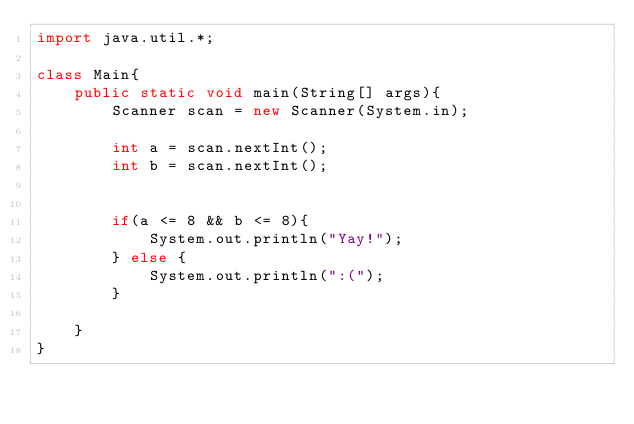Convert code to text. <code><loc_0><loc_0><loc_500><loc_500><_Java_>import java.util.*;

class Main{
	public static void main(String[] args){
		Scanner scan = new Scanner(System.in);

		int a = scan.nextInt();
		int b = scan.nextInt();


		if(a <= 8 && b <= 8){
			System.out.println("Yay!");
		} else {
			System.out.println(":(");
		}

	}
}
</code> 